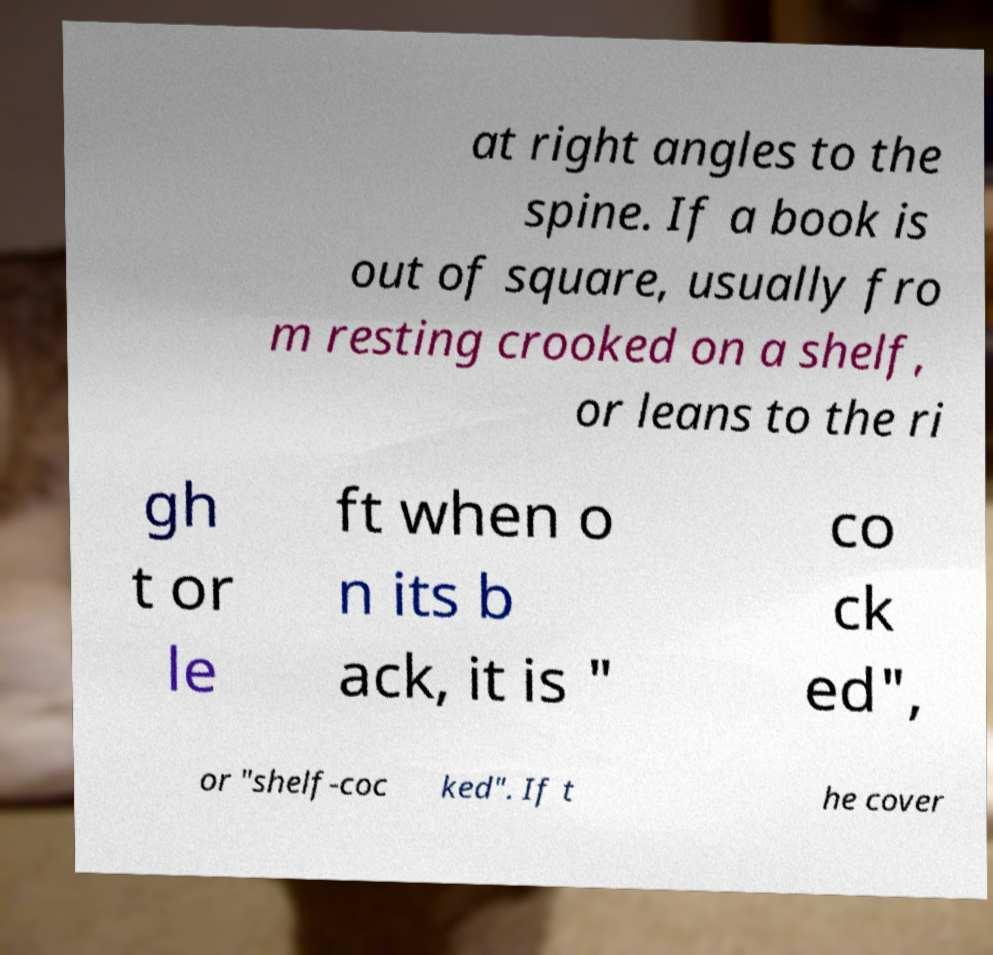Could you extract and type out the text from this image? at right angles to the spine. If a book is out of square, usually fro m resting crooked on a shelf, or leans to the ri gh t or le ft when o n its b ack, it is " co ck ed", or "shelf-coc ked". If t he cover 